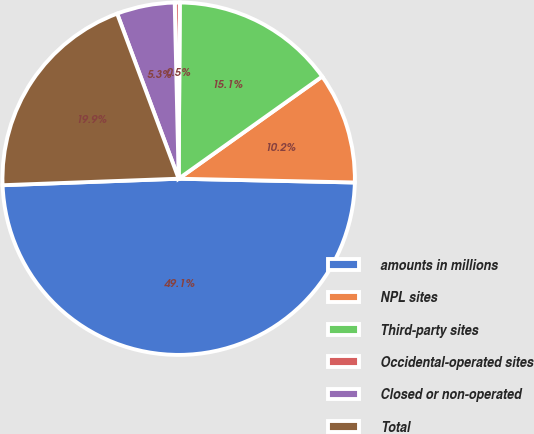<chart> <loc_0><loc_0><loc_500><loc_500><pie_chart><fcel>amounts in millions<fcel>NPL sites<fcel>Third-party sites<fcel>Occidental-operated sites<fcel>Closed or non-operated<fcel>Total<nl><fcel>49.07%<fcel>10.19%<fcel>15.05%<fcel>0.46%<fcel>5.32%<fcel>19.91%<nl></chart> 